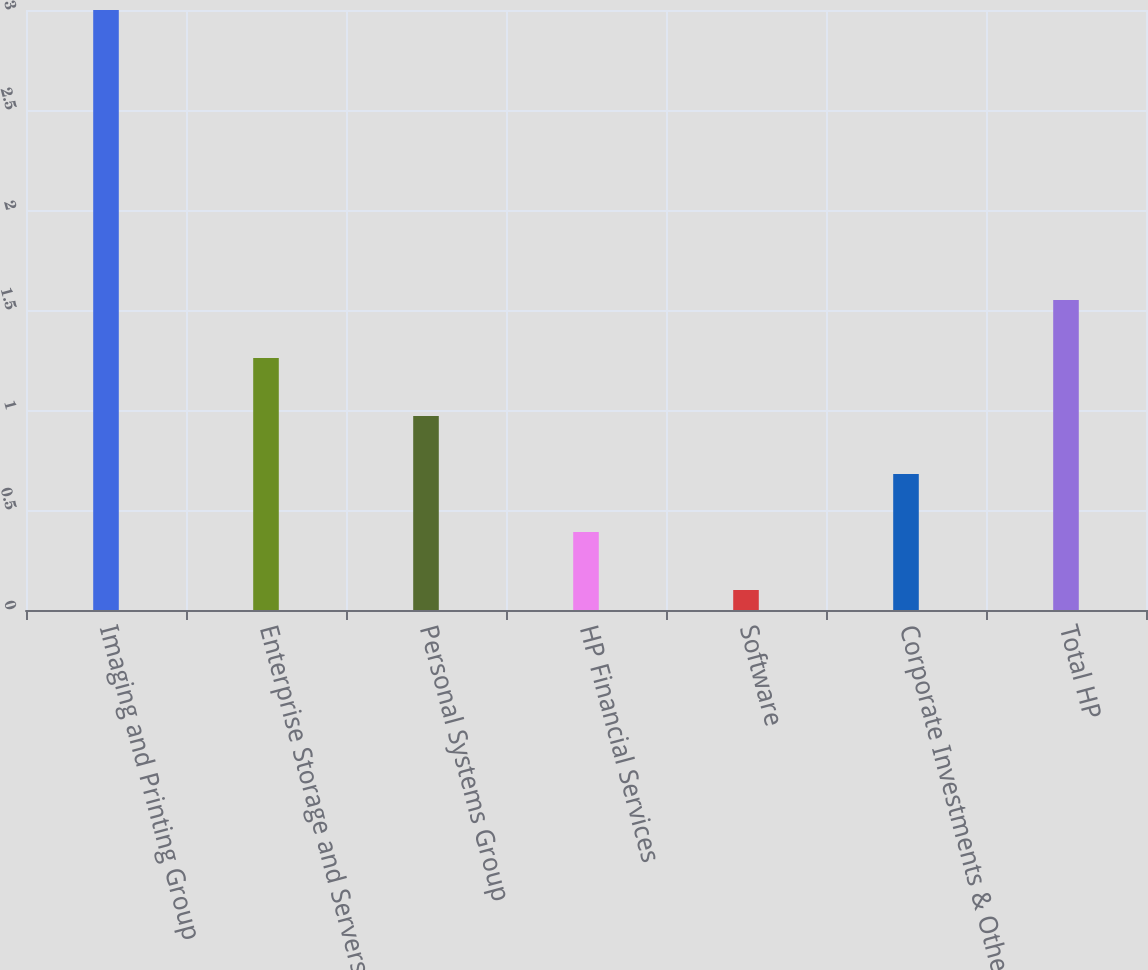Convert chart to OTSL. <chart><loc_0><loc_0><loc_500><loc_500><bar_chart><fcel>Imaging and Printing Group<fcel>Enterprise Storage and Servers<fcel>Personal Systems Group<fcel>HP Financial Services<fcel>Software<fcel>Corporate Investments & Other<fcel>Total HP<nl><fcel>3<fcel>1.26<fcel>0.97<fcel>0.39<fcel>0.1<fcel>0.68<fcel>1.55<nl></chart> 